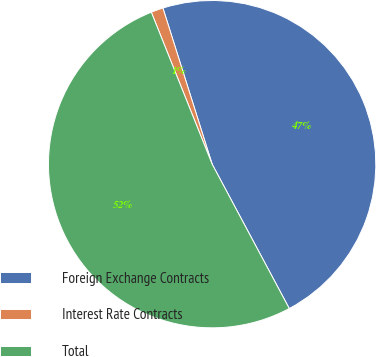Convert chart. <chart><loc_0><loc_0><loc_500><loc_500><pie_chart><fcel>Foreign Exchange Contracts<fcel>Interest Rate Contracts<fcel>Total<nl><fcel>47.05%<fcel>1.2%<fcel>51.75%<nl></chart> 